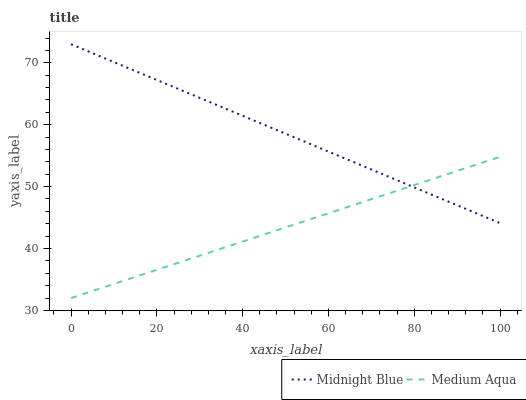Does Medium Aqua have the minimum area under the curve?
Answer yes or no. Yes. Does Midnight Blue have the maximum area under the curve?
Answer yes or no. Yes. Does Midnight Blue have the minimum area under the curve?
Answer yes or no. No. Is Medium Aqua the smoothest?
Answer yes or no. Yes. Is Midnight Blue the roughest?
Answer yes or no. Yes. Is Midnight Blue the smoothest?
Answer yes or no. No. Does Medium Aqua have the lowest value?
Answer yes or no. Yes. Does Midnight Blue have the lowest value?
Answer yes or no. No. Does Midnight Blue have the highest value?
Answer yes or no. Yes. Does Midnight Blue intersect Medium Aqua?
Answer yes or no. Yes. Is Midnight Blue less than Medium Aqua?
Answer yes or no. No. Is Midnight Blue greater than Medium Aqua?
Answer yes or no. No. 